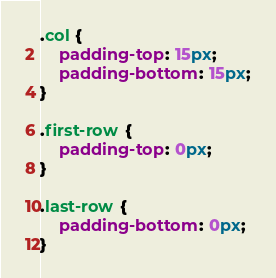<code> <loc_0><loc_0><loc_500><loc_500><_CSS_>.col {
	padding-top: 15px;
	padding-bottom: 15px;
}

.first-row {
	padding-top: 0px;
}

.last-row {
	padding-bottom: 0px;
}
</code> 